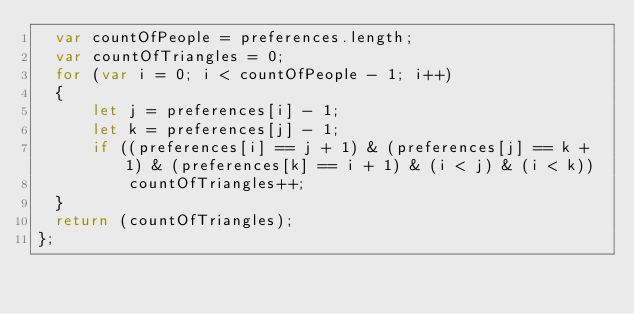<code> <loc_0><loc_0><loc_500><loc_500><_JavaScript_>  var countOfPeople = preferences.length;
  var countOfTriangles = 0;
  for (var i = 0; i < countOfPeople - 1; i++)
  {
      let j = preferences[i] - 1;
      let k = preferences[j] - 1;
      if ((preferences[i] == j + 1) & (preferences[j] == k + 1) & (preferences[k] == i + 1) & (i < j) & (i < k))
          countOfTriangles++;
  }
  return (countOfTriangles);
};
</code> 